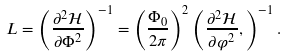<formula> <loc_0><loc_0><loc_500><loc_500>L = \left ( \frac { \partial ^ { 2 } \mathcal { H } } { \partial \Phi ^ { 2 } } \right ) ^ { - 1 } = \left ( \frac { \Phi _ { 0 } } { 2 \pi } \right ) ^ { 2 } \left ( \frac { \partial ^ { 2 } \mathcal { H } } { \partial \varphi ^ { 2 } } , \right ) ^ { - 1 } .</formula> 